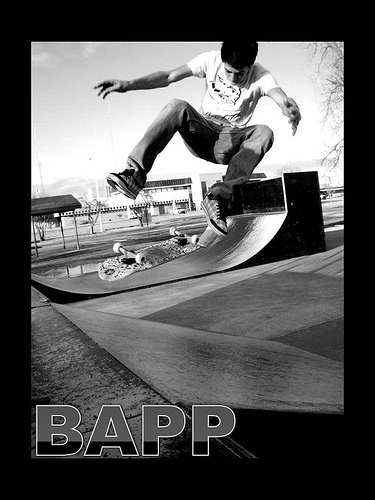What trick might the skateboarder be performing in this image? The skateboarder appears to be performing an 'ollie,' which is a fundamental trick where the rider and board leap into the air without the use of the rider's hands. What aspects of the image suggest that this is a skilled skateboarder? The skateboarder's control and form, indicated by their balanced posture and the height at which they're executing the ollie, demonstrate a level of skill. Additionally, the location at a skate park suggests that they practice regularly. 